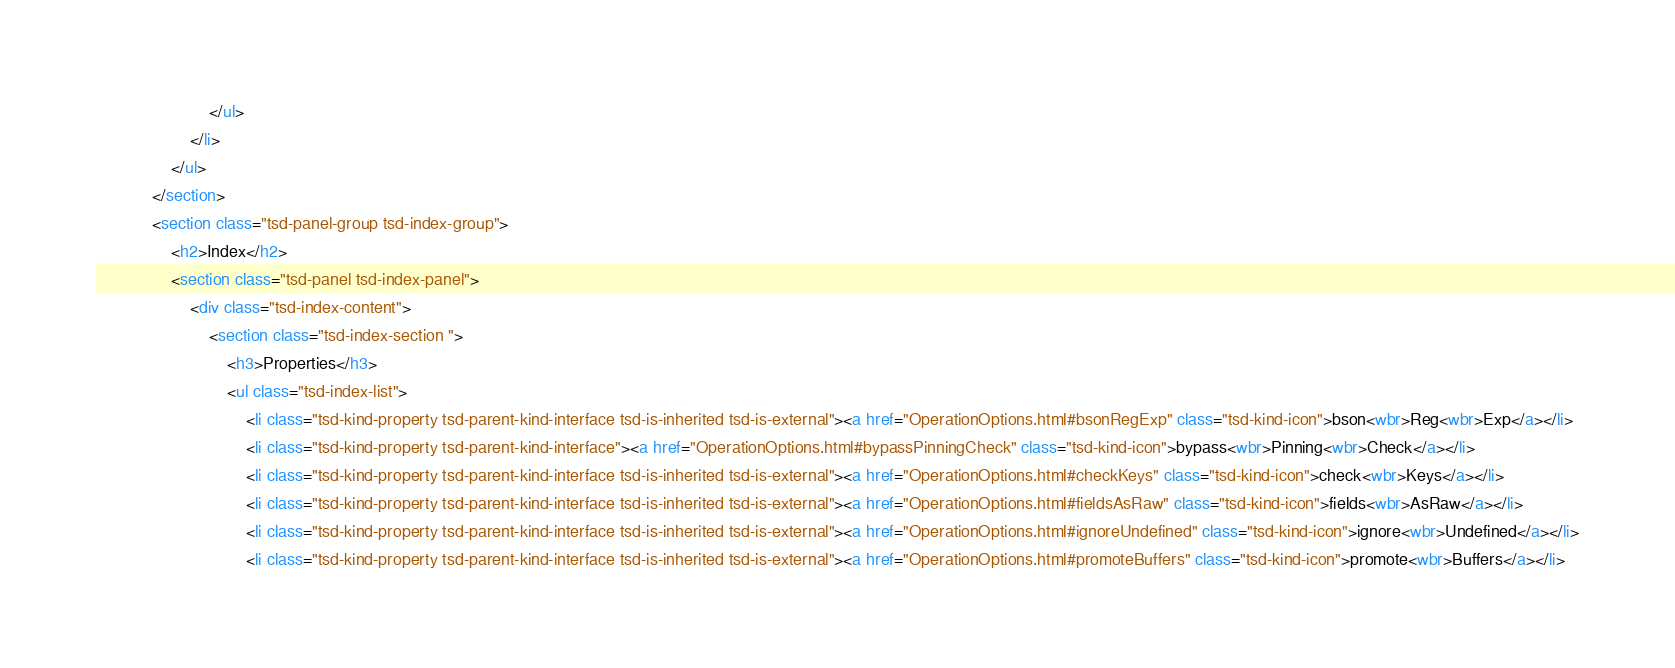Convert code to text. <code><loc_0><loc_0><loc_500><loc_500><_HTML_>						</ul>
					</li>
				</ul>
			</section>
			<section class="tsd-panel-group tsd-index-group">
				<h2>Index</h2>
				<section class="tsd-panel tsd-index-panel">
					<div class="tsd-index-content">
						<section class="tsd-index-section ">
							<h3>Properties</h3>
							<ul class="tsd-index-list">
								<li class="tsd-kind-property tsd-parent-kind-interface tsd-is-inherited tsd-is-external"><a href="OperationOptions.html#bsonRegExp" class="tsd-kind-icon">bson<wbr>Reg<wbr>Exp</a></li>
								<li class="tsd-kind-property tsd-parent-kind-interface"><a href="OperationOptions.html#bypassPinningCheck" class="tsd-kind-icon">bypass<wbr>Pinning<wbr>Check</a></li>
								<li class="tsd-kind-property tsd-parent-kind-interface tsd-is-inherited tsd-is-external"><a href="OperationOptions.html#checkKeys" class="tsd-kind-icon">check<wbr>Keys</a></li>
								<li class="tsd-kind-property tsd-parent-kind-interface tsd-is-inherited tsd-is-external"><a href="OperationOptions.html#fieldsAsRaw" class="tsd-kind-icon">fields<wbr>AsRaw</a></li>
								<li class="tsd-kind-property tsd-parent-kind-interface tsd-is-inherited tsd-is-external"><a href="OperationOptions.html#ignoreUndefined" class="tsd-kind-icon">ignore<wbr>Undefined</a></li>
								<li class="tsd-kind-property tsd-parent-kind-interface tsd-is-inherited tsd-is-external"><a href="OperationOptions.html#promoteBuffers" class="tsd-kind-icon">promote<wbr>Buffers</a></li></code> 